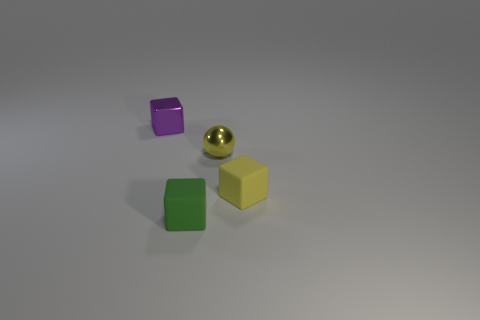What number of things are either small rubber blocks behind the green matte thing or yellow shiny spheres behind the small green matte thing?
Offer a terse response. 2. There is a cube that is the same color as the shiny sphere; what is its material?
Offer a very short reply. Rubber. Are there fewer tiny yellow spheres on the right side of the yellow block than tiny green things in front of the purple metallic cube?
Your answer should be very brief. Yes. Is the material of the sphere the same as the tiny green block?
Your response must be concise. No. What size is the cube that is in front of the tiny yellow metallic sphere and on the left side of the small sphere?
Ensure brevity in your answer.  Small. The yellow matte thing that is the same size as the shiny sphere is what shape?
Offer a terse response. Cube. What is the material of the small yellow object in front of the metal object that is right of the tiny object behind the yellow metallic thing?
Give a very brief answer. Rubber. Does the tiny metal thing that is behind the tiny yellow shiny ball have the same shape as the small green object that is in front of the tiny yellow shiny object?
Offer a terse response. Yes. What number of other objects are there of the same material as the tiny purple object?
Ensure brevity in your answer.  1. Is the small cube that is to the left of the tiny green object made of the same material as the block that is to the right of the green rubber object?
Offer a terse response. No. 